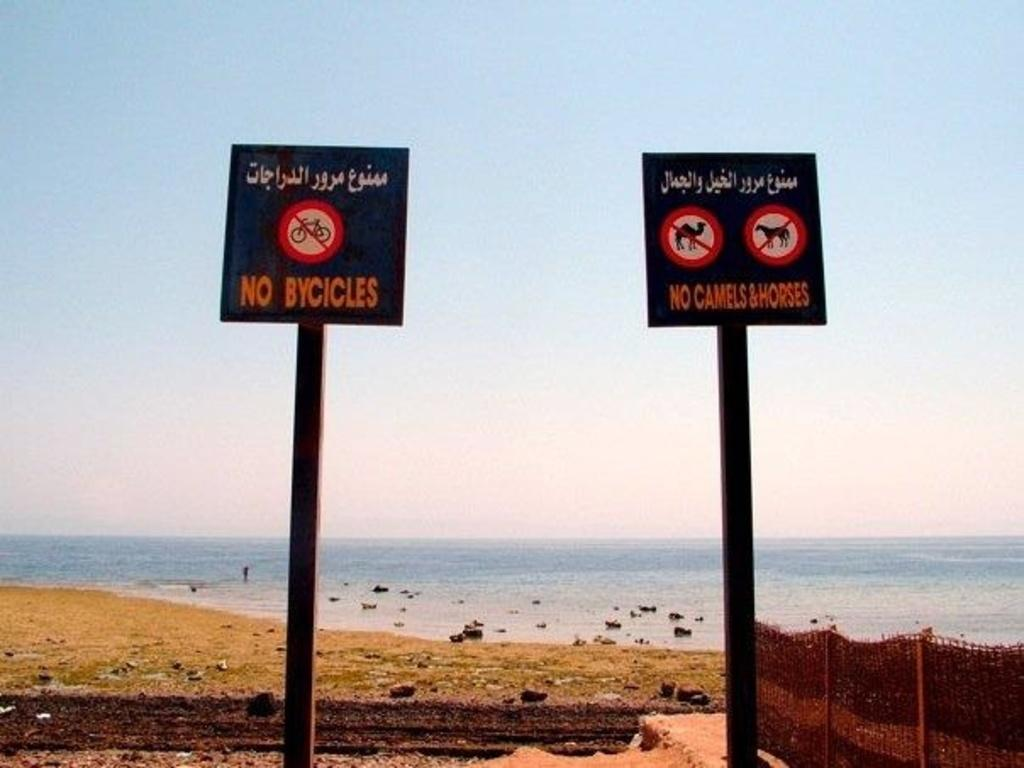<image>
Relay a brief, clear account of the picture shown. Signs that prohibit bicycles and camels and horses. 